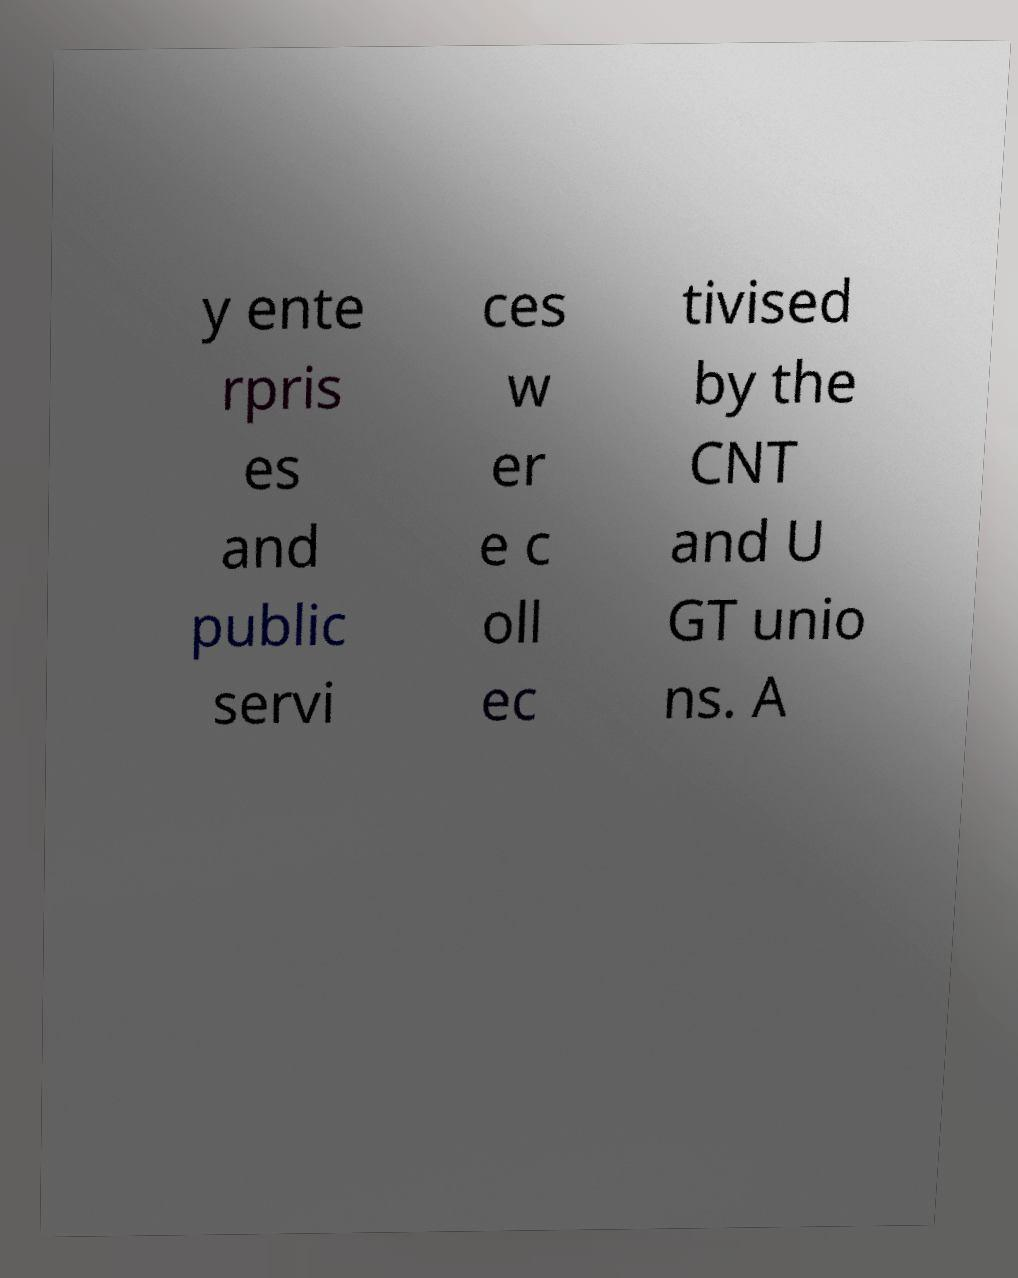Could you assist in decoding the text presented in this image and type it out clearly? y ente rpris es and public servi ces w er e c oll ec tivised by the CNT and U GT unio ns. A 